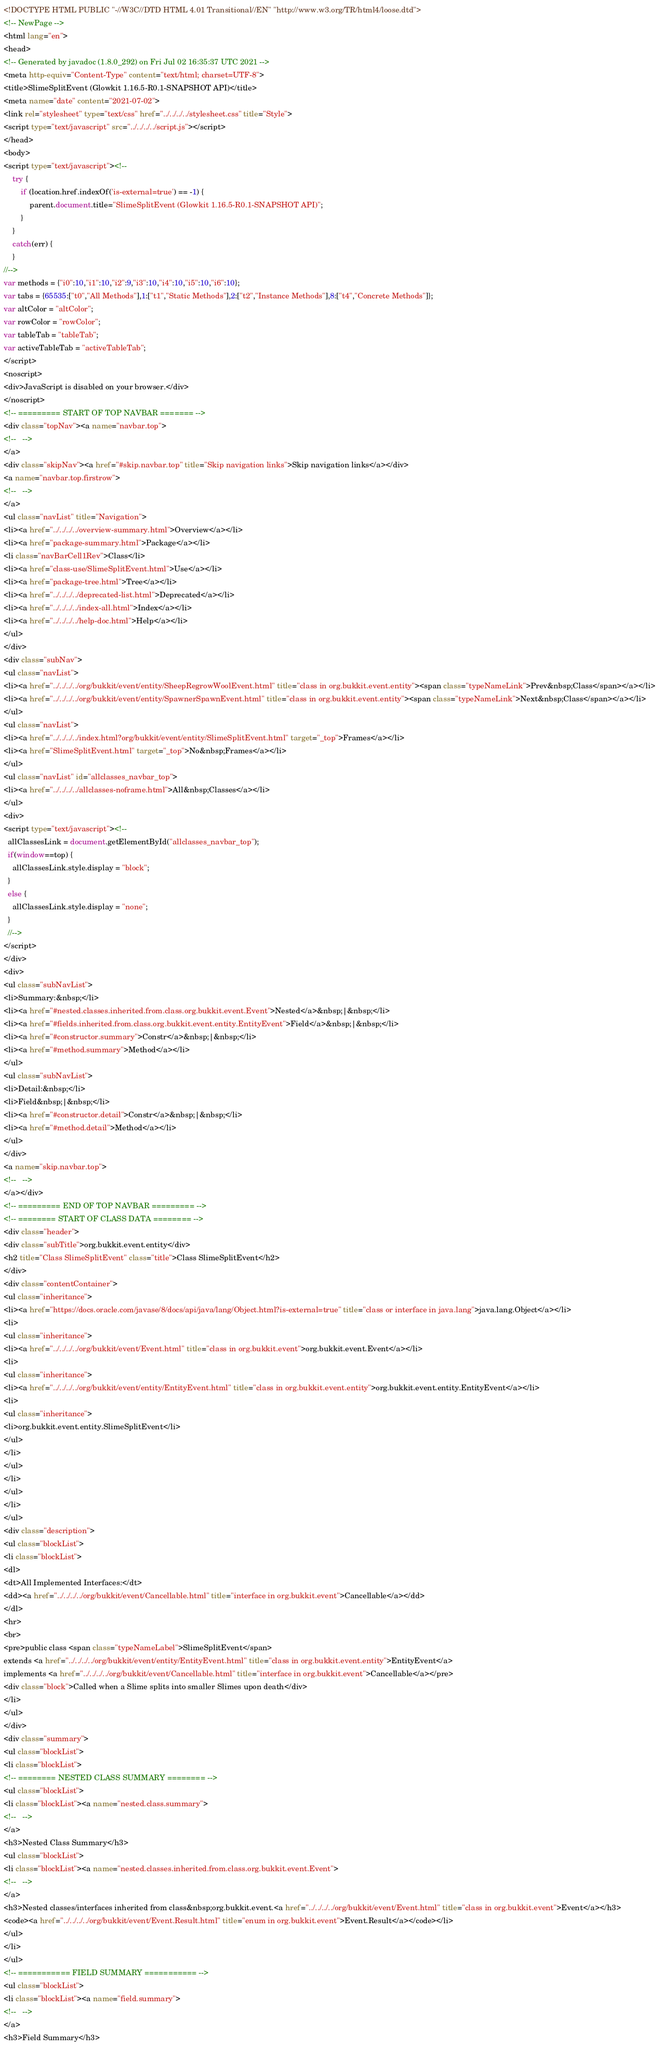<code> <loc_0><loc_0><loc_500><loc_500><_HTML_><!DOCTYPE HTML PUBLIC "-//W3C//DTD HTML 4.01 Transitional//EN" "http://www.w3.org/TR/html4/loose.dtd">
<!-- NewPage -->
<html lang="en">
<head>
<!-- Generated by javadoc (1.8.0_292) on Fri Jul 02 16:35:37 UTC 2021 -->
<meta http-equiv="Content-Type" content="text/html; charset=UTF-8">
<title>SlimeSplitEvent (Glowkit 1.16.5-R0.1-SNAPSHOT API)</title>
<meta name="date" content="2021-07-02">
<link rel="stylesheet" type="text/css" href="../../../../stylesheet.css" title="Style">
<script type="text/javascript" src="../../../../script.js"></script>
</head>
<body>
<script type="text/javascript"><!--
    try {
        if (location.href.indexOf('is-external=true') == -1) {
            parent.document.title="SlimeSplitEvent (Glowkit 1.16.5-R0.1-SNAPSHOT API)";
        }
    }
    catch(err) {
    }
//-->
var methods = {"i0":10,"i1":10,"i2":9,"i3":10,"i4":10,"i5":10,"i6":10};
var tabs = {65535:["t0","All Methods"],1:["t1","Static Methods"],2:["t2","Instance Methods"],8:["t4","Concrete Methods"]};
var altColor = "altColor";
var rowColor = "rowColor";
var tableTab = "tableTab";
var activeTableTab = "activeTableTab";
</script>
<noscript>
<div>JavaScript is disabled on your browser.</div>
</noscript>
<!-- ========= START OF TOP NAVBAR ======= -->
<div class="topNav"><a name="navbar.top">
<!--   -->
</a>
<div class="skipNav"><a href="#skip.navbar.top" title="Skip navigation links">Skip navigation links</a></div>
<a name="navbar.top.firstrow">
<!--   -->
</a>
<ul class="navList" title="Navigation">
<li><a href="../../../../overview-summary.html">Overview</a></li>
<li><a href="package-summary.html">Package</a></li>
<li class="navBarCell1Rev">Class</li>
<li><a href="class-use/SlimeSplitEvent.html">Use</a></li>
<li><a href="package-tree.html">Tree</a></li>
<li><a href="../../../../deprecated-list.html">Deprecated</a></li>
<li><a href="../../../../index-all.html">Index</a></li>
<li><a href="../../../../help-doc.html">Help</a></li>
</ul>
</div>
<div class="subNav">
<ul class="navList">
<li><a href="../../../../org/bukkit/event/entity/SheepRegrowWoolEvent.html" title="class in org.bukkit.event.entity"><span class="typeNameLink">Prev&nbsp;Class</span></a></li>
<li><a href="../../../../org/bukkit/event/entity/SpawnerSpawnEvent.html" title="class in org.bukkit.event.entity"><span class="typeNameLink">Next&nbsp;Class</span></a></li>
</ul>
<ul class="navList">
<li><a href="../../../../index.html?org/bukkit/event/entity/SlimeSplitEvent.html" target="_top">Frames</a></li>
<li><a href="SlimeSplitEvent.html" target="_top">No&nbsp;Frames</a></li>
</ul>
<ul class="navList" id="allclasses_navbar_top">
<li><a href="../../../../allclasses-noframe.html">All&nbsp;Classes</a></li>
</ul>
<div>
<script type="text/javascript"><!--
  allClassesLink = document.getElementById("allclasses_navbar_top");
  if(window==top) {
    allClassesLink.style.display = "block";
  }
  else {
    allClassesLink.style.display = "none";
  }
  //-->
</script>
</div>
<div>
<ul class="subNavList">
<li>Summary:&nbsp;</li>
<li><a href="#nested.classes.inherited.from.class.org.bukkit.event.Event">Nested</a>&nbsp;|&nbsp;</li>
<li><a href="#fields.inherited.from.class.org.bukkit.event.entity.EntityEvent">Field</a>&nbsp;|&nbsp;</li>
<li><a href="#constructor.summary">Constr</a>&nbsp;|&nbsp;</li>
<li><a href="#method.summary">Method</a></li>
</ul>
<ul class="subNavList">
<li>Detail:&nbsp;</li>
<li>Field&nbsp;|&nbsp;</li>
<li><a href="#constructor.detail">Constr</a>&nbsp;|&nbsp;</li>
<li><a href="#method.detail">Method</a></li>
</ul>
</div>
<a name="skip.navbar.top">
<!--   -->
</a></div>
<!-- ========= END OF TOP NAVBAR ========= -->
<!-- ======== START OF CLASS DATA ======== -->
<div class="header">
<div class="subTitle">org.bukkit.event.entity</div>
<h2 title="Class SlimeSplitEvent" class="title">Class SlimeSplitEvent</h2>
</div>
<div class="contentContainer">
<ul class="inheritance">
<li><a href="https://docs.oracle.com/javase/8/docs/api/java/lang/Object.html?is-external=true" title="class or interface in java.lang">java.lang.Object</a></li>
<li>
<ul class="inheritance">
<li><a href="../../../../org/bukkit/event/Event.html" title="class in org.bukkit.event">org.bukkit.event.Event</a></li>
<li>
<ul class="inheritance">
<li><a href="../../../../org/bukkit/event/entity/EntityEvent.html" title="class in org.bukkit.event.entity">org.bukkit.event.entity.EntityEvent</a></li>
<li>
<ul class="inheritance">
<li>org.bukkit.event.entity.SlimeSplitEvent</li>
</ul>
</li>
</ul>
</li>
</ul>
</li>
</ul>
<div class="description">
<ul class="blockList">
<li class="blockList">
<dl>
<dt>All Implemented Interfaces:</dt>
<dd><a href="../../../../org/bukkit/event/Cancellable.html" title="interface in org.bukkit.event">Cancellable</a></dd>
</dl>
<hr>
<br>
<pre>public class <span class="typeNameLabel">SlimeSplitEvent</span>
extends <a href="../../../../org/bukkit/event/entity/EntityEvent.html" title="class in org.bukkit.event.entity">EntityEvent</a>
implements <a href="../../../../org/bukkit/event/Cancellable.html" title="interface in org.bukkit.event">Cancellable</a></pre>
<div class="block">Called when a Slime splits into smaller Slimes upon death</div>
</li>
</ul>
</div>
<div class="summary">
<ul class="blockList">
<li class="blockList">
<!-- ======== NESTED CLASS SUMMARY ======== -->
<ul class="blockList">
<li class="blockList"><a name="nested.class.summary">
<!--   -->
</a>
<h3>Nested Class Summary</h3>
<ul class="blockList">
<li class="blockList"><a name="nested.classes.inherited.from.class.org.bukkit.event.Event">
<!--   -->
</a>
<h3>Nested classes/interfaces inherited from class&nbsp;org.bukkit.event.<a href="../../../../org/bukkit/event/Event.html" title="class in org.bukkit.event">Event</a></h3>
<code><a href="../../../../org/bukkit/event/Event.Result.html" title="enum in org.bukkit.event">Event.Result</a></code></li>
</ul>
</li>
</ul>
<!-- =========== FIELD SUMMARY =========== -->
<ul class="blockList">
<li class="blockList"><a name="field.summary">
<!--   -->
</a>
<h3>Field Summary</h3></code> 